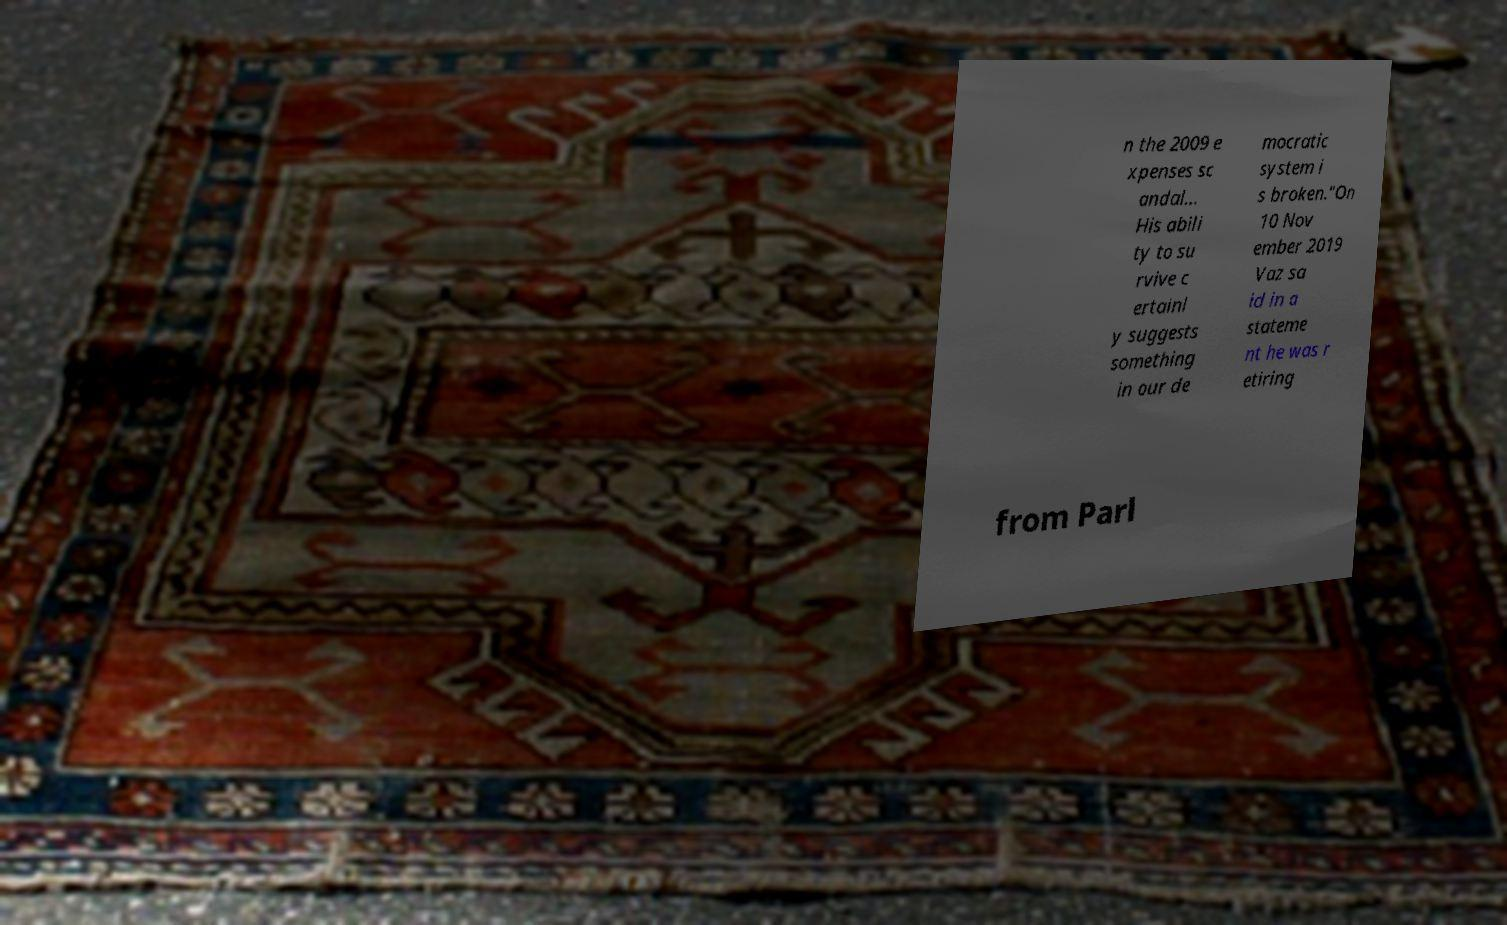There's text embedded in this image that I need extracted. Can you transcribe it verbatim? n the 2009 e xpenses sc andal... His abili ty to su rvive c ertainl y suggests something in our de mocratic system i s broken."On 10 Nov ember 2019 Vaz sa id in a stateme nt he was r etiring from Parl 